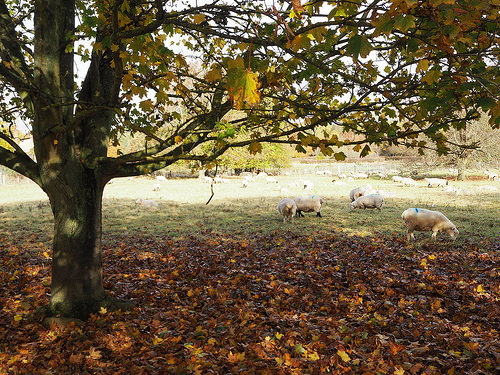<image>
Can you confirm if the tree is in the ground? Yes. The tree is contained within or inside the ground, showing a containment relationship. Where is the tree in relation to the sheep? Is it in front of the sheep? Yes. The tree is positioned in front of the sheep, appearing closer to the camera viewpoint. 